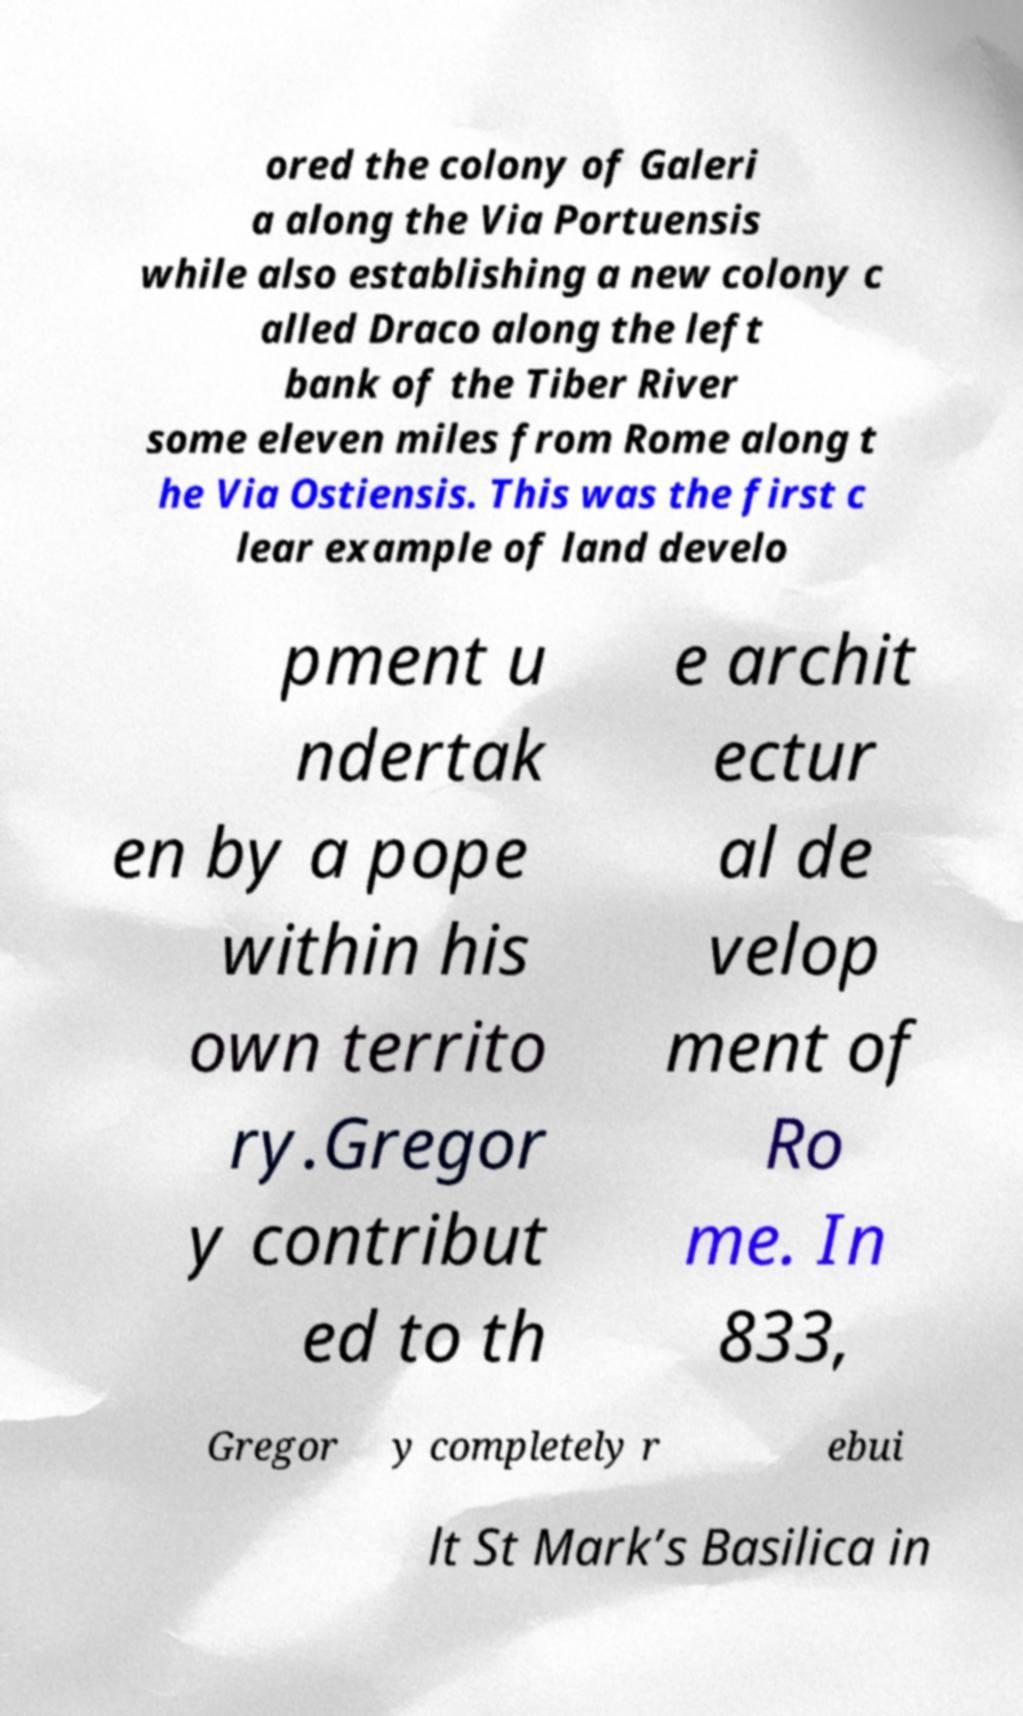What messages or text are displayed in this image? I need them in a readable, typed format. ored the colony of Galeri a along the Via Portuensis while also establishing a new colony c alled Draco along the left bank of the Tiber River some eleven miles from Rome along t he Via Ostiensis. This was the first c lear example of land develo pment u ndertak en by a pope within his own territo ry.Gregor y contribut ed to th e archit ectur al de velop ment of Ro me. In 833, Gregor y completely r ebui lt St Mark’s Basilica in 